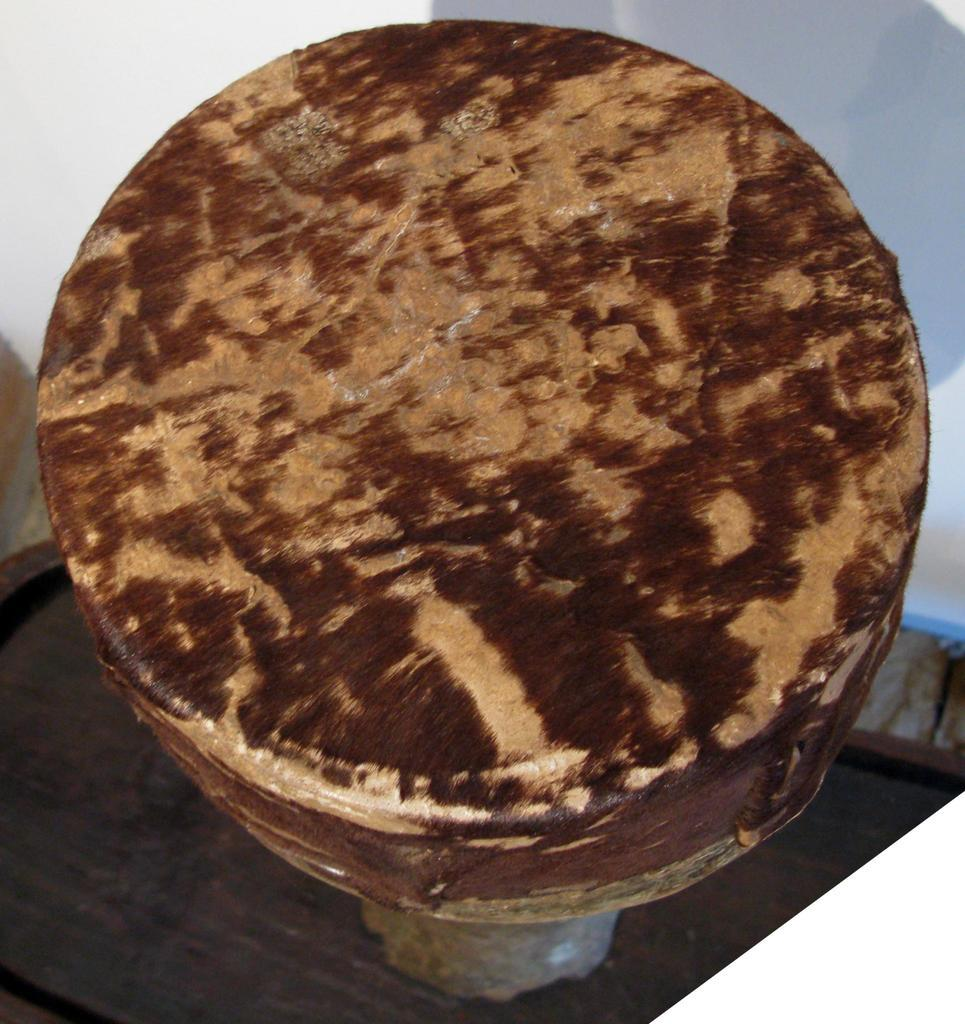What material is the main object in the image made of? The main object in the image is made of wood. What can be seen in the background of the image? There is a wall in the background of the image. What type of plate is being used by the horn player's partner in the image? There is no plate, horn player, or partner present in the image. 